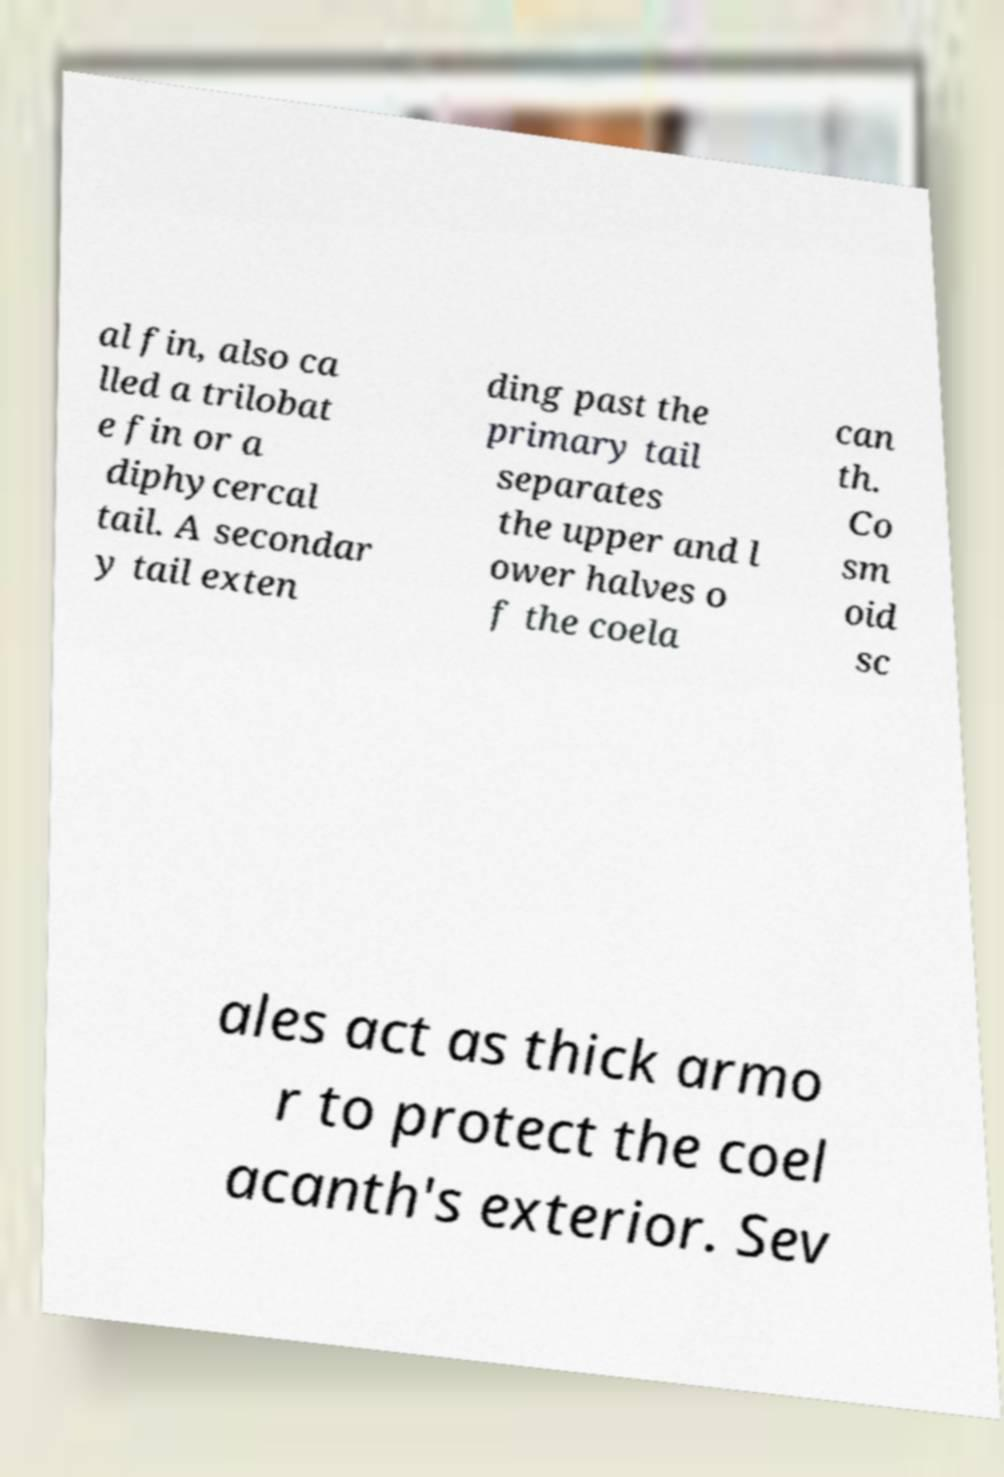Can you accurately transcribe the text from the provided image for me? al fin, also ca lled a trilobat e fin or a diphycercal tail. A secondar y tail exten ding past the primary tail separates the upper and l ower halves o f the coela can th. Co sm oid sc ales act as thick armo r to protect the coel acanth's exterior. Sev 